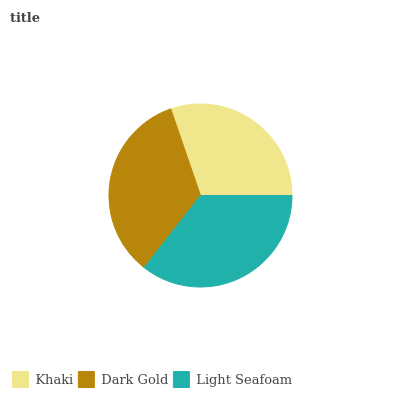Is Khaki the minimum?
Answer yes or no. Yes. Is Light Seafoam the maximum?
Answer yes or no. Yes. Is Dark Gold the minimum?
Answer yes or no. No. Is Dark Gold the maximum?
Answer yes or no. No. Is Dark Gold greater than Khaki?
Answer yes or no. Yes. Is Khaki less than Dark Gold?
Answer yes or no. Yes. Is Khaki greater than Dark Gold?
Answer yes or no. No. Is Dark Gold less than Khaki?
Answer yes or no. No. Is Dark Gold the high median?
Answer yes or no. Yes. Is Dark Gold the low median?
Answer yes or no. Yes. Is Light Seafoam the high median?
Answer yes or no. No. Is Light Seafoam the low median?
Answer yes or no. No. 